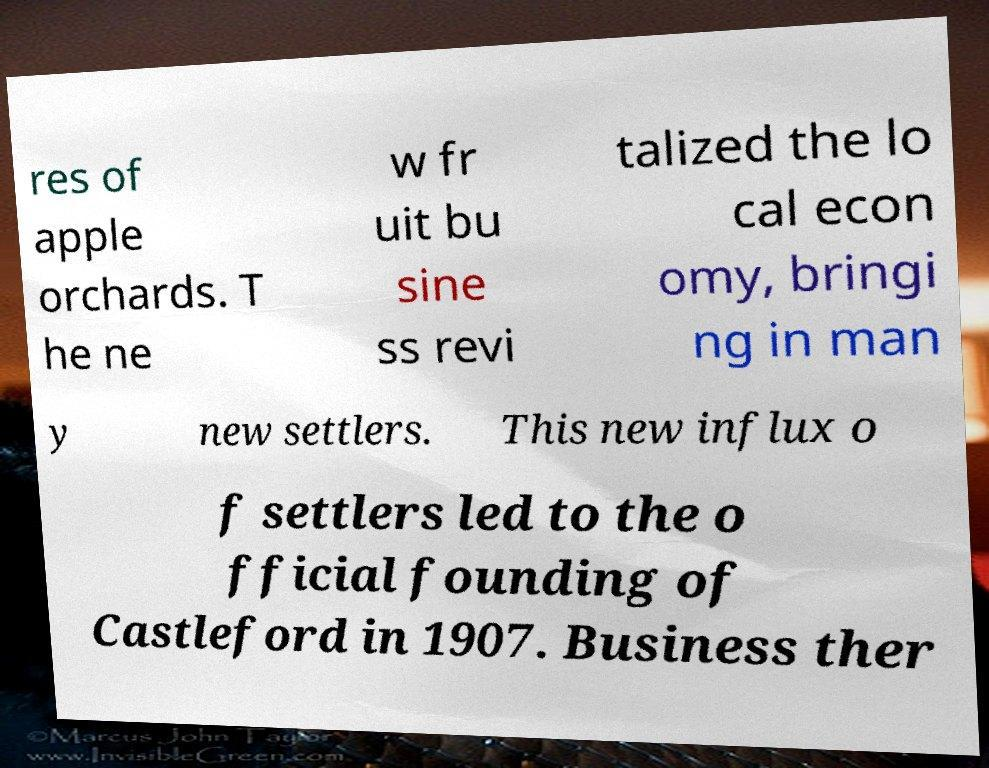Could you assist in decoding the text presented in this image and type it out clearly? res of apple orchards. T he ne w fr uit bu sine ss revi talized the lo cal econ omy, bringi ng in man y new settlers. This new influx o f settlers led to the o fficial founding of Castleford in 1907. Business ther 